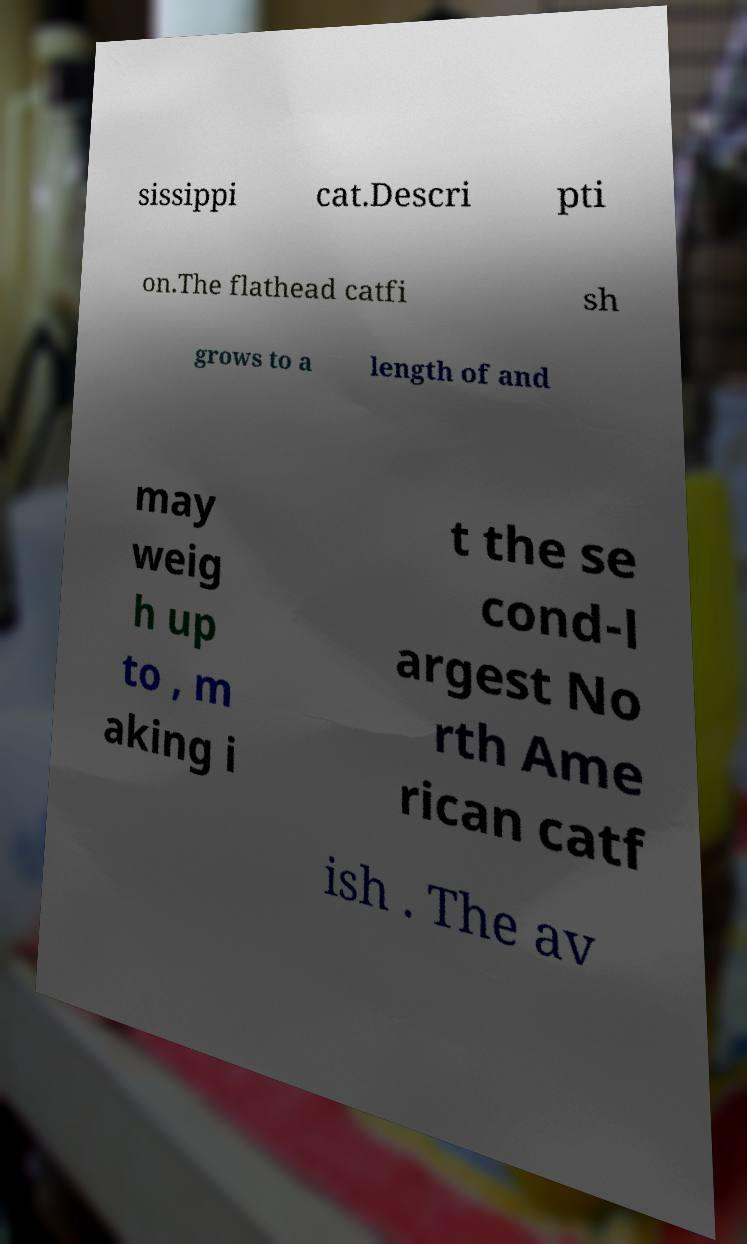Please read and relay the text visible in this image. What does it say? sissippi cat.Descri pti on.The flathead catfi sh grows to a length of and may weig h up to , m aking i t the se cond-l argest No rth Ame rican catf ish . The av 